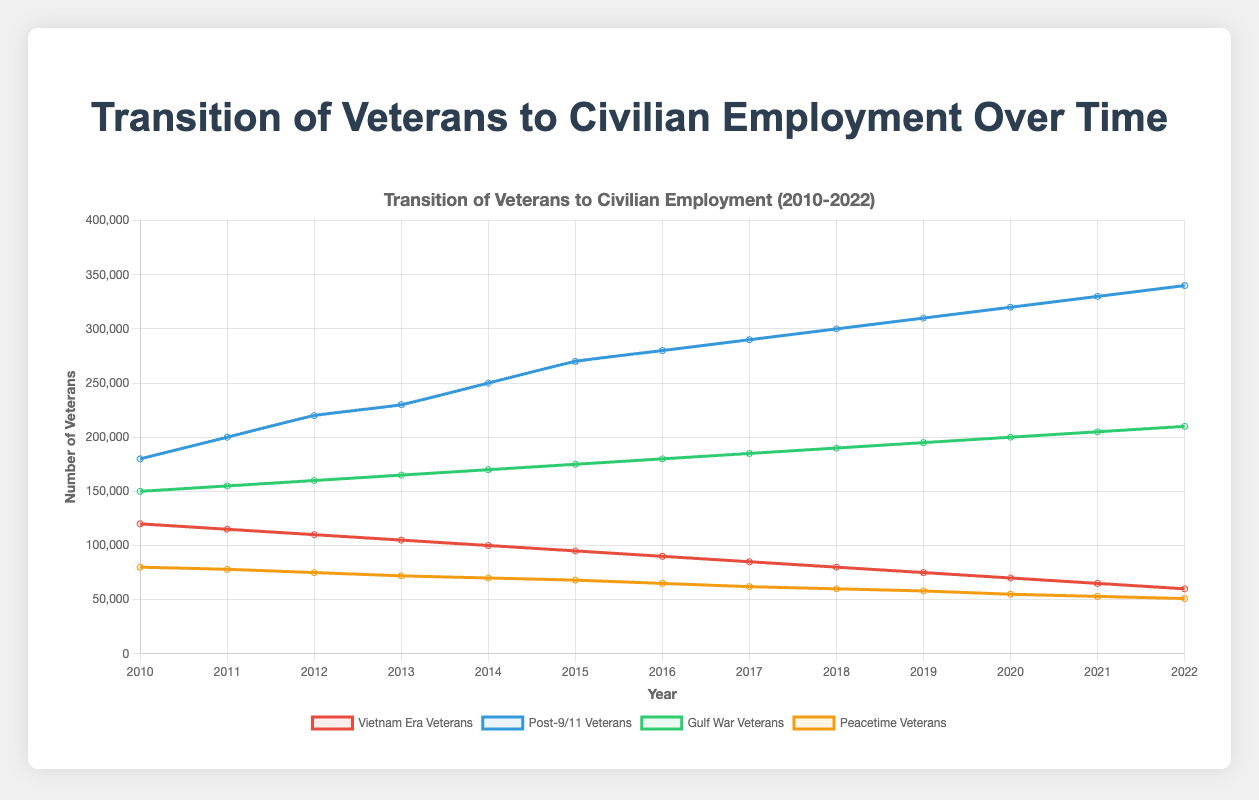What year did the number of Post-9/11 Veterans surpass 300,000? The line for Post-9/11 Veterans crosses the 300,000 mark between the years 2018 and 2019. So we identify 2018 as the year where the data hits 300,000.
Answer: 2018 Which group had the largest increase in the number of veterans from 2010 to 2022? By subtracting the numbers for each group in 2022 from their respective numbers in 2010, we get: Vietnam Era: 120,000-60,000=60,000 decrease, Post-9/11: 340,000-180,000=160,000 increase, Gulf War: 210,000-150,000=60,000 increase, Peacetime: 80,000-51,000=29,000 decrease. Post-9/11 Veterans had the largest increase.
Answer: Post-9/11 Veterans What is the trend in the number of Peacetime Veterans from 2010 to 2022? Observing the line for Peacetime Veterans, it consistently declines from 80,000 in 2010 to 51,000 in 2022.
Answer: Decreasing In what year did the number of Gulf War Veterans reach 190,000? Following the line for Gulf War Veterans, it hits 190,000 at the year 2018.
Answer: 2018 Which group had the smallest number of veterans in 2022? In the year 2022, by comparing the end of each line, the Peacetime Veterans have the smallest count at 51,000.
Answer: Peacetime Veterans How does the number of Vietnam Era Veterans in 2010 compare to the number in 2022? The number of Vietnam Era Veterans decreases from 120,000 in 2010 to 60,000 in 2022.
Answer: Decreased By how much did the number of Post-9/11 Veterans increase between 2015 and 2022? Subtract the number of Post-9/11 Veterans in 2015 from the number in 2022: 340,000 - 270,000 = 70,000.
Answer: 70,000 What year saw the biggest jump in the number of Post-9/11 Veterans? By evaluating year-over-year increments, the biggest increase occurred from 2013 to 2014, where the number rose by 20,000 (230,000 to 250,000).
Answer: 2014 Which groups experienced a continuous decline over the years 2010-2022? Both Vietnam Era Veterans and Peacetime Veterans show a continuous decrease in numbers from 2010 to 2022.
Answer: Vietnam Era Veterans, Peacetime Veterans 